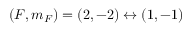Convert formula to latex. <formula><loc_0><loc_0><loc_500><loc_500>( F , m _ { F } ) = ( 2 , - 2 ) \leftrightarrow ( 1 , - 1 )</formula> 